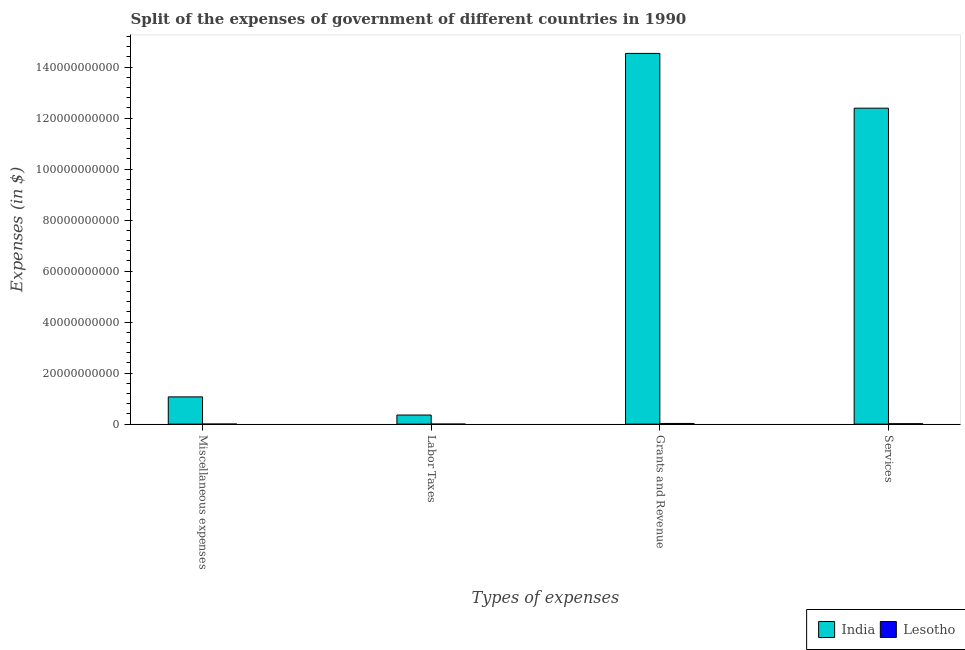How many different coloured bars are there?
Keep it short and to the point. 2. Are the number of bars per tick equal to the number of legend labels?
Offer a very short reply. Yes. What is the label of the 1st group of bars from the left?
Provide a succinct answer. Miscellaneous expenses. What is the amount spent on services in India?
Make the answer very short. 1.24e+11. Across all countries, what is the maximum amount spent on services?
Ensure brevity in your answer.  1.24e+11. Across all countries, what is the minimum amount spent on grants and revenue?
Your answer should be very brief. 2.58e+08. In which country was the amount spent on grants and revenue maximum?
Your answer should be very brief. India. In which country was the amount spent on miscellaneous expenses minimum?
Provide a short and direct response. Lesotho. What is the total amount spent on labor taxes in the graph?
Your answer should be very brief. 3.56e+09. What is the difference between the amount spent on grants and revenue in Lesotho and that in India?
Provide a short and direct response. -1.45e+11. What is the difference between the amount spent on miscellaneous expenses in India and the amount spent on services in Lesotho?
Ensure brevity in your answer.  1.05e+1. What is the average amount spent on labor taxes per country?
Offer a terse response. 1.78e+09. What is the difference between the amount spent on services and amount spent on miscellaneous expenses in Lesotho?
Provide a succinct answer. 1.31e+08. In how many countries, is the amount spent on labor taxes greater than 80000000000 $?
Provide a short and direct response. 0. What is the ratio of the amount spent on labor taxes in India to that in Lesotho?
Make the answer very short. 3946.78. What is the difference between the highest and the second highest amount spent on grants and revenue?
Keep it short and to the point. 1.45e+11. What is the difference between the highest and the lowest amount spent on services?
Offer a very short reply. 1.24e+11. In how many countries, is the amount spent on services greater than the average amount spent on services taken over all countries?
Your answer should be very brief. 1. What does the 2nd bar from the left in Grants and Revenue represents?
Give a very brief answer. Lesotho. What does the 1st bar from the right in Grants and Revenue represents?
Give a very brief answer. Lesotho. Is it the case that in every country, the sum of the amount spent on miscellaneous expenses and amount spent on labor taxes is greater than the amount spent on grants and revenue?
Keep it short and to the point. No. How many bars are there?
Make the answer very short. 8. Are all the bars in the graph horizontal?
Make the answer very short. No. How many countries are there in the graph?
Provide a succinct answer. 2. What is the difference between two consecutive major ticks on the Y-axis?
Ensure brevity in your answer.  2.00e+1. Are the values on the major ticks of Y-axis written in scientific E-notation?
Offer a terse response. No. Does the graph contain grids?
Your response must be concise. No. How many legend labels are there?
Give a very brief answer. 2. What is the title of the graph?
Offer a terse response. Split of the expenses of government of different countries in 1990. Does "Vietnam" appear as one of the legend labels in the graph?
Offer a very short reply. No. What is the label or title of the X-axis?
Make the answer very short. Types of expenses. What is the label or title of the Y-axis?
Offer a terse response. Expenses (in $). What is the Expenses (in $) of India in Miscellaneous expenses?
Offer a very short reply. 1.07e+1. What is the Expenses (in $) of Lesotho in Miscellaneous expenses?
Provide a short and direct response. 1.37e+07. What is the Expenses (in $) in India in Labor Taxes?
Ensure brevity in your answer.  3.56e+09. What is the Expenses (in $) of Lesotho in Labor Taxes?
Offer a terse response. 9.02e+05. What is the Expenses (in $) in India in Grants and Revenue?
Offer a very short reply. 1.45e+11. What is the Expenses (in $) in Lesotho in Grants and Revenue?
Offer a terse response. 2.58e+08. What is the Expenses (in $) of India in Services?
Make the answer very short. 1.24e+11. What is the Expenses (in $) in Lesotho in Services?
Provide a succinct answer. 1.45e+08. Across all Types of expenses, what is the maximum Expenses (in $) in India?
Provide a succinct answer. 1.45e+11. Across all Types of expenses, what is the maximum Expenses (in $) in Lesotho?
Make the answer very short. 2.58e+08. Across all Types of expenses, what is the minimum Expenses (in $) of India?
Your answer should be compact. 3.56e+09. Across all Types of expenses, what is the minimum Expenses (in $) in Lesotho?
Make the answer very short. 9.02e+05. What is the total Expenses (in $) of India in the graph?
Make the answer very short. 2.84e+11. What is the total Expenses (in $) of Lesotho in the graph?
Keep it short and to the point. 4.17e+08. What is the difference between the Expenses (in $) in India in Miscellaneous expenses and that in Labor Taxes?
Provide a succinct answer. 7.12e+09. What is the difference between the Expenses (in $) of Lesotho in Miscellaneous expenses and that in Labor Taxes?
Your response must be concise. 1.28e+07. What is the difference between the Expenses (in $) in India in Miscellaneous expenses and that in Grants and Revenue?
Provide a short and direct response. -1.35e+11. What is the difference between the Expenses (in $) in Lesotho in Miscellaneous expenses and that in Grants and Revenue?
Your response must be concise. -2.44e+08. What is the difference between the Expenses (in $) of India in Miscellaneous expenses and that in Services?
Your response must be concise. -1.13e+11. What is the difference between the Expenses (in $) of Lesotho in Miscellaneous expenses and that in Services?
Your answer should be compact. -1.31e+08. What is the difference between the Expenses (in $) of India in Labor Taxes and that in Grants and Revenue?
Provide a succinct answer. -1.42e+11. What is the difference between the Expenses (in $) of Lesotho in Labor Taxes and that in Grants and Revenue?
Your answer should be compact. -2.57e+08. What is the difference between the Expenses (in $) in India in Labor Taxes and that in Services?
Provide a succinct answer. -1.20e+11. What is the difference between the Expenses (in $) of Lesotho in Labor Taxes and that in Services?
Offer a terse response. -1.44e+08. What is the difference between the Expenses (in $) of India in Grants and Revenue and that in Services?
Make the answer very short. 2.15e+1. What is the difference between the Expenses (in $) of Lesotho in Grants and Revenue and that in Services?
Offer a very short reply. 1.13e+08. What is the difference between the Expenses (in $) of India in Miscellaneous expenses and the Expenses (in $) of Lesotho in Labor Taxes?
Ensure brevity in your answer.  1.07e+1. What is the difference between the Expenses (in $) of India in Miscellaneous expenses and the Expenses (in $) of Lesotho in Grants and Revenue?
Offer a very short reply. 1.04e+1. What is the difference between the Expenses (in $) of India in Miscellaneous expenses and the Expenses (in $) of Lesotho in Services?
Your answer should be compact. 1.05e+1. What is the difference between the Expenses (in $) in India in Labor Taxes and the Expenses (in $) in Lesotho in Grants and Revenue?
Your answer should be compact. 3.30e+09. What is the difference between the Expenses (in $) in India in Labor Taxes and the Expenses (in $) in Lesotho in Services?
Offer a terse response. 3.42e+09. What is the difference between the Expenses (in $) of India in Grants and Revenue and the Expenses (in $) of Lesotho in Services?
Give a very brief answer. 1.45e+11. What is the average Expenses (in $) of India per Types of expenses?
Ensure brevity in your answer.  7.09e+1. What is the average Expenses (in $) of Lesotho per Types of expenses?
Make the answer very short. 1.04e+08. What is the difference between the Expenses (in $) in India and Expenses (in $) in Lesotho in Miscellaneous expenses?
Provide a succinct answer. 1.07e+1. What is the difference between the Expenses (in $) of India and Expenses (in $) of Lesotho in Labor Taxes?
Ensure brevity in your answer.  3.56e+09. What is the difference between the Expenses (in $) of India and Expenses (in $) of Lesotho in Grants and Revenue?
Give a very brief answer. 1.45e+11. What is the difference between the Expenses (in $) of India and Expenses (in $) of Lesotho in Services?
Give a very brief answer. 1.24e+11. What is the ratio of the Expenses (in $) in India in Miscellaneous expenses to that in Labor Taxes?
Offer a very short reply. 3. What is the ratio of the Expenses (in $) of Lesotho in Miscellaneous expenses to that in Labor Taxes?
Make the answer very short. 15.19. What is the ratio of the Expenses (in $) in India in Miscellaneous expenses to that in Grants and Revenue?
Your answer should be compact. 0.07. What is the ratio of the Expenses (in $) in Lesotho in Miscellaneous expenses to that in Grants and Revenue?
Your answer should be compact. 0.05. What is the ratio of the Expenses (in $) in India in Miscellaneous expenses to that in Services?
Your answer should be compact. 0.09. What is the ratio of the Expenses (in $) of Lesotho in Miscellaneous expenses to that in Services?
Offer a terse response. 0.09. What is the ratio of the Expenses (in $) in India in Labor Taxes to that in Grants and Revenue?
Give a very brief answer. 0.02. What is the ratio of the Expenses (in $) of Lesotho in Labor Taxes to that in Grants and Revenue?
Make the answer very short. 0. What is the ratio of the Expenses (in $) of India in Labor Taxes to that in Services?
Your response must be concise. 0.03. What is the ratio of the Expenses (in $) in Lesotho in Labor Taxes to that in Services?
Offer a terse response. 0.01. What is the ratio of the Expenses (in $) in India in Grants and Revenue to that in Services?
Keep it short and to the point. 1.17. What is the ratio of the Expenses (in $) in Lesotho in Grants and Revenue to that in Services?
Keep it short and to the point. 1.78. What is the difference between the highest and the second highest Expenses (in $) of India?
Offer a very short reply. 2.15e+1. What is the difference between the highest and the second highest Expenses (in $) in Lesotho?
Offer a terse response. 1.13e+08. What is the difference between the highest and the lowest Expenses (in $) in India?
Give a very brief answer. 1.42e+11. What is the difference between the highest and the lowest Expenses (in $) of Lesotho?
Provide a short and direct response. 2.57e+08. 